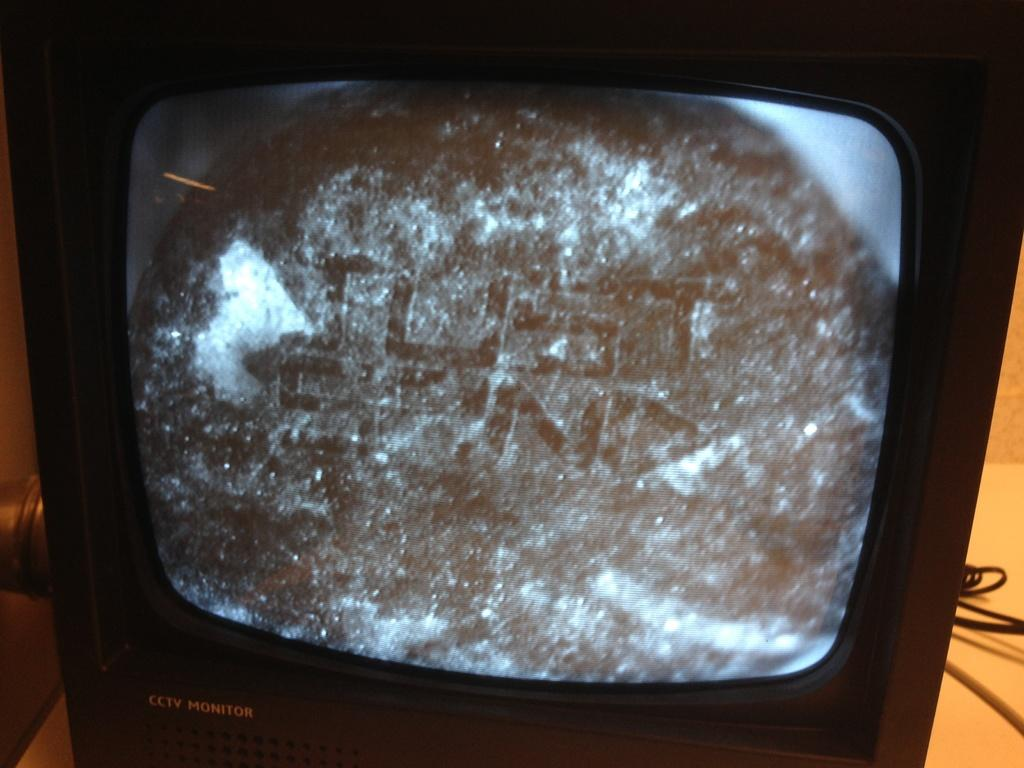<image>
Render a clear and concise summary of the photo. A TV says CCTV Monitor on the front and shows a fuzzy screen. 